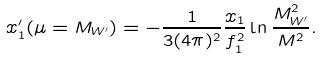Convert formula to latex. <formula><loc_0><loc_0><loc_500><loc_500>x _ { 1 } ^ { \prime } ( \mu = M _ { W ^ { \prime } } ) = - \frac { 1 } { 3 ( 4 \pi ) ^ { 2 } } \frac { x _ { 1 } } { f _ { 1 } ^ { 2 } } \ln \frac { M _ { W ^ { \prime } } ^ { 2 } } { M ^ { 2 } } .</formula> 